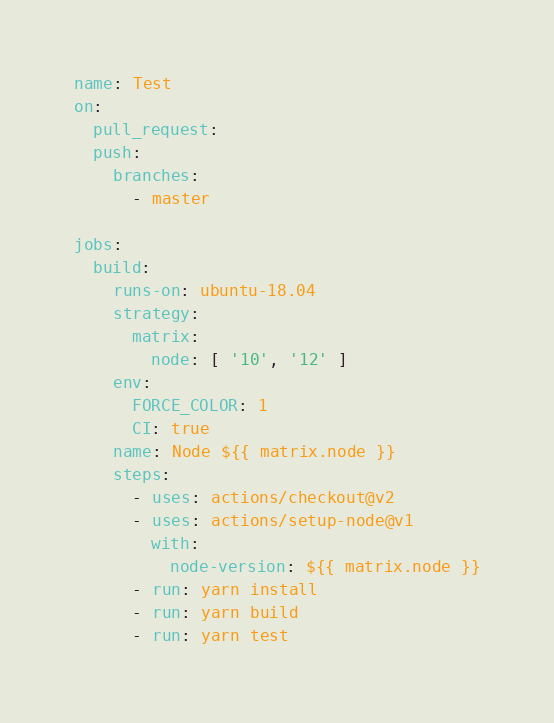<code> <loc_0><loc_0><loc_500><loc_500><_YAML_>name: Test
on:
  pull_request:
  push:
    branches:
      - master

jobs:
  build:
    runs-on: ubuntu-18.04
    strategy:
      matrix:
        node: [ '10', '12' ]
    env:
      FORCE_COLOR: 1
      CI: true
    name: Node ${{ matrix.node }}
    steps:
      - uses: actions/checkout@v2
      - uses: actions/setup-node@v1
        with:
          node-version: ${{ matrix.node }}
      - run: yarn install
      - run: yarn build
      - run: yarn test
</code> 